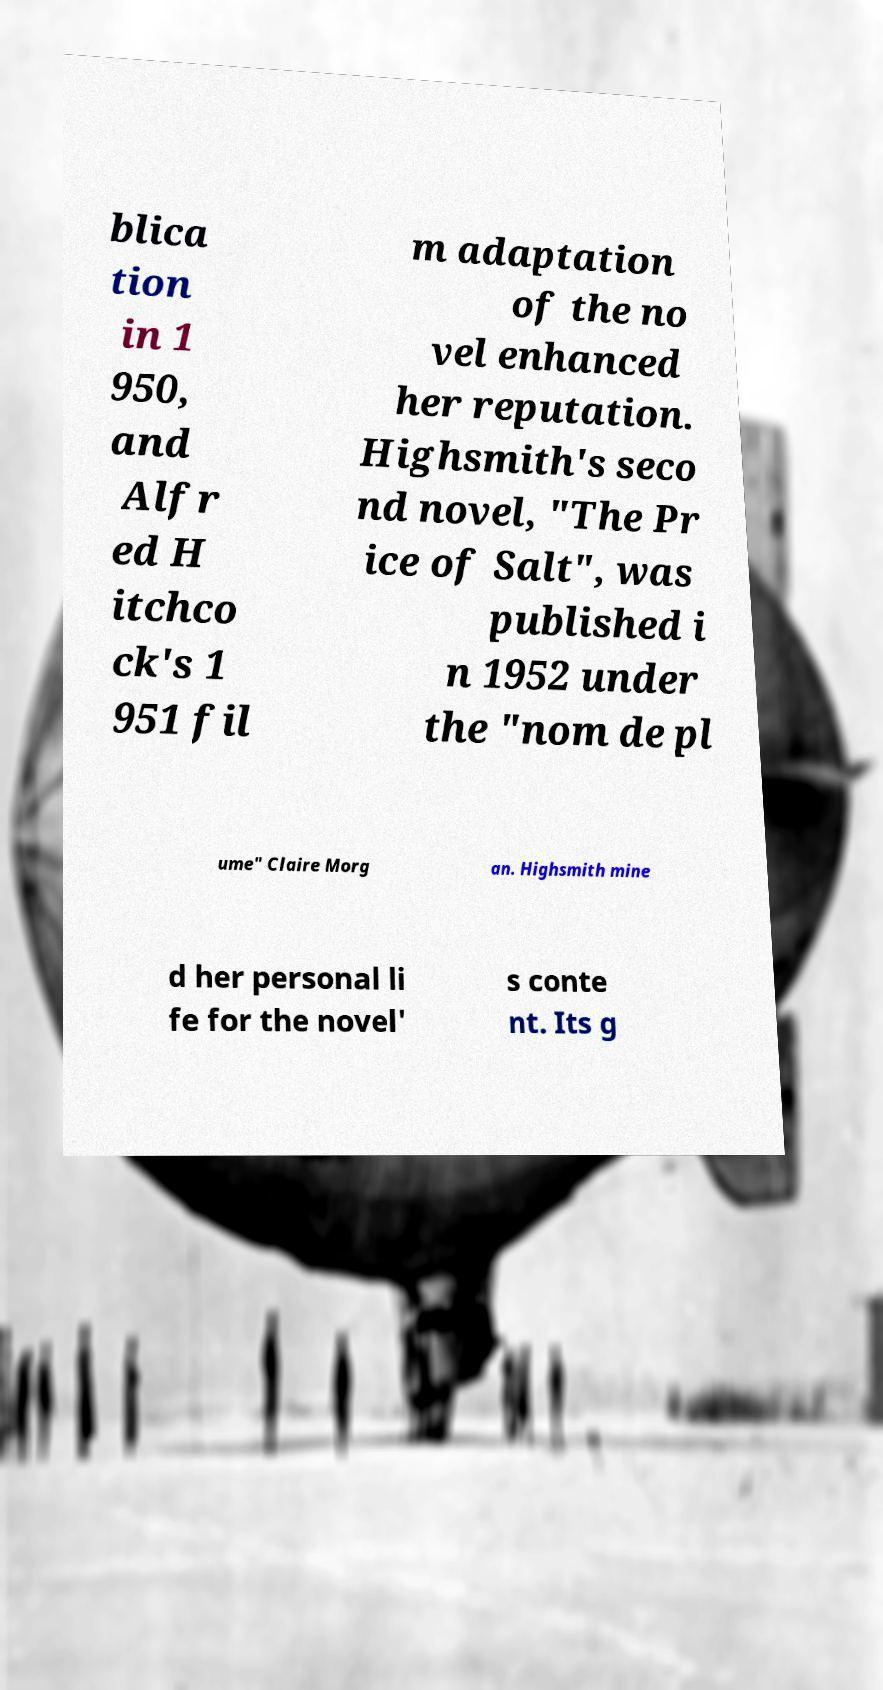Can you read and provide the text displayed in the image?This photo seems to have some interesting text. Can you extract and type it out for me? blica tion in 1 950, and Alfr ed H itchco ck's 1 951 fil m adaptation of the no vel enhanced her reputation. Highsmith's seco nd novel, "The Pr ice of Salt", was published i n 1952 under the "nom de pl ume" Claire Morg an. Highsmith mine d her personal li fe for the novel' s conte nt. Its g 